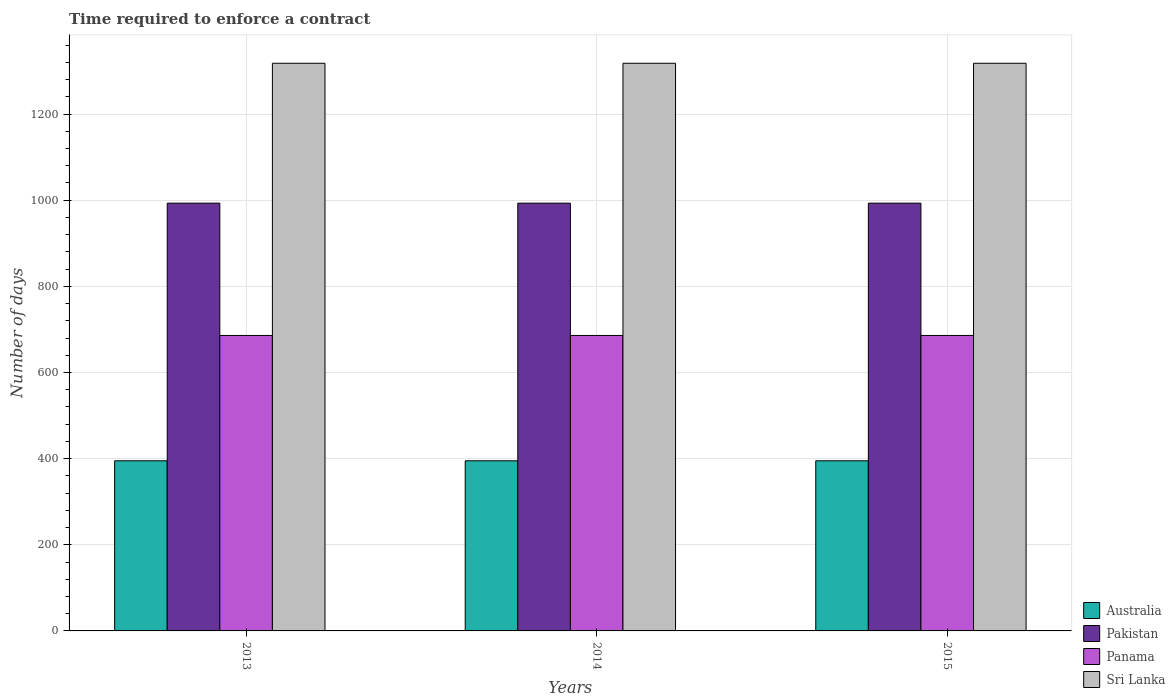How many different coloured bars are there?
Offer a very short reply. 4. Are the number of bars per tick equal to the number of legend labels?
Keep it short and to the point. Yes. Are the number of bars on each tick of the X-axis equal?
Ensure brevity in your answer.  Yes. How many bars are there on the 2nd tick from the right?
Your response must be concise. 4. What is the label of the 3rd group of bars from the left?
Ensure brevity in your answer.  2015. What is the number of days required to enforce a contract in Australia in 2013?
Provide a short and direct response. 395. Across all years, what is the maximum number of days required to enforce a contract in Australia?
Offer a terse response. 395. Across all years, what is the minimum number of days required to enforce a contract in Sri Lanka?
Offer a terse response. 1318. What is the total number of days required to enforce a contract in Pakistan in the graph?
Keep it short and to the point. 2979.6. What is the difference between the number of days required to enforce a contract in Australia in 2013 and that in 2015?
Provide a succinct answer. 0. What is the difference between the number of days required to enforce a contract in Pakistan in 2014 and the number of days required to enforce a contract in Sri Lanka in 2013?
Provide a short and direct response. -324.8. What is the average number of days required to enforce a contract in Pakistan per year?
Make the answer very short. 993.2. In the year 2014, what is the difference between the number of days required to enforce a contract in Sri Lanka and number of days required to enforce a contract in Australia?
Provide a succinct answer. 923. In how many years, is the number of days required to enforce a contract in Australia greater than 440 days?
Ensure brevity in your answer.  0. Is the number of days required to enforce a contract in Pakistan in 2013 less than that in 2014?
Offer a terse response. No. Is the difference between the number of days required to enforce a contract in Sri Lanka in 2013 and 2015 greater than the difference between the number of days required to enforce a contract in Australia in 2013 and 2015?
Offer a very short reply. No. What is the difference between the highest and the lowest number of days required to enforce a contract in Panama?
Your answer should be very brief. 0. What does the 4th bar from the left in 2015 represents?
Ensure brevity in your answer.  Sri Lanka. What does the 3rd bar from the right in 2013 represents?
Provide a succinct answer. Pakistan. Is it the case that in every year, the sum of the number of days required to enforce a contract in Australia and number of days required to enforce a contract in Pakistan is greater than the number of days required to enforce a contract in Panama?
Your response must be concise. Yes. How many bars are there?
Provide a succinct answer. 12. How many years are there in the graph?
Make the answer very short. 3. Does the graph contain any zero values?
Your answer should be compact. No. What is the title of the graph?
Keep it short and to the point. Time required to enforce a contract. What is the label or title of the Y-axis?
Make the answer very short. Number of days. What is the Number of days in Australia in 2013?
Make the answer very short. 395. What is the Number of days of Pakistan in 2013?
Offer a very short reply. 993.2. What is the Number of days in Panama in 2013?
Your answer should be very brief. 686. What is the Number of days of Sri Lanka in 2013?
Ensure brevity in your answer.  1318. What is the Number of days in Australia in 2014?
Offer a very short reply. 395. What is the Number of days of Pakistan in 2014?
Give a very brief answer. 993.2. What is the Number of days in Panama in 2014?
Your answer should be very brief. 686. What is the Number of days in Sri Lanka in 2014?
Keep it short and to the point. 1318. What is the Number of days of Australia in 2015?
Your answer should be compact. 395. What is the Number of days in Pakistan in 2015?
Your response must be concise. 993.2. What is the Number of days in Panama in 2015?
Provide a short and direct response. 686. What is the Number of days in Sri Lanka in 2015?
Your response must be concise. 1318. Across all years, what is the maximum Number of days of Australia?
Keep it short and to the point. 395. Across all years, what is the maximum Number of days of Pakistan?
Provide a short and direct response. 993.2. Across all years, what is the maximum Number of days in Panama?
Give a very brief answer. 686. Across all years, what is the maximum Number of days of Sri Lanka?
Your answer should be compact. 1318. Across all years, what is the minimum Number of days in Australia?
Your response must be concise. 395. Across all years, what is the minimum Number of days of Pakistan?
Your response must be concise. 993.2. Across all years, what is the minimum Number of days of Panama?
Your answer should be compact. 686. Across all years, what is the minimum Number of days in Sri Lanka?
Provide a short and direct response. 1318. What is the total Number of days in Australia in the graph?
Your answer should be compact. 1185. What is the total Number of days in Pakistan in the graph?
Your answer should be compact. 2979.6. What is the total Number of days in Panama in the graph?
Provide a succinct answer. 2058. What is the total Number of days of Sri Lanka in the graph?
Provide a succinct answer. 3954. What is the difference between the Number of days in Pakistan in 2013 and that in 2015?
Make the answer very short. 0. What is the difference between the Number of days in Sri Lanka in 2014 and that in 2015?
Make the answer very short. 0. What is the difference between the Number of days of Australia in 2013 and the Number of days of Pakistan in 2014?
Your response must be concise. -598.2. What is the difference between the Number of days in Australia in 2013 and the Number of days in Panama in 2014?
Provide a succinct answer. -291. What is the difference between the Number of days of Australia in 2013 and the Number of days of Sri Lanka in 2014?
Offer a terse response. -923. What is the difference between the Number of days of Pakistan in 2013 and the Number of days of Panama in 2014?
Offer a very short reply. 307.2. What is the difference between the Number of days in Pakistan in 2013 and the Number of days in Sri Lanka in 2014?
Provide a short and direct response. -324.8. What is the difference between the Number of days of Panama in 2013 and the Number of days of Sri Lanka in 2014?
Your response must be concise. -632. What is the difference between the Number of days in Australia in 2013 and the Number of days in Pakistan in 2015?
Make the answer very short. -598.2. What is the difference between the Number of days of Australia in 2013 and the Number of days of Panama in 2015?
Offer a terse response. -291. What is the difference between the Number of days in Australia in 2013 and the Number of days in Sri Lanka in 2015?
Give a very brief answer. -923. What is the difference between the Number of days in Pakistan in 2013 and the Number of days in Panama in 2015?
Your response must be concise. 307.2. What is the difference between the Number of days in Pakistan in 2013 and the Number of days in Sri Lanka in 2015?
Provide a short and direct response. -324.8. What is the difference between the Number of days of Panama in 2013 and the Number of days of Sri Lanka in 2015?
Your answer should be compact. -632. What is the difference between the Number of days in Australia in 2014 and the Number of days in Pakistan in 2015?
Provide a succinct answer. -598.2. What is the difference between the Number of days of Australia in 2014 and the Number of days of Panama in 2015?
Your answer should be very brief. -291. What is the difference between the Number of days in Australia in 2014 and the Number of days in Sri Lanka in 2015?
Your answer should be compact. -923. What is the difference between the Number of days of Pakistan in 2014 and the Number of days of Panama in 2015?
Ensure brevity in your answer.  307.2. What is the difference between the Number of days in Pakistan in 2014 and the Number of days in Sri Lanka in 2015?
Keep it short and to the point. -324.8. What is the difference between the Number of days of Panama in 2014 and the Number of days of Sri Lanka in 2015?
Your answer should be compact. -632. What is the average Number of days of Australia per year?
Provide a short and direct response. 395. What is the average Number of days in Pakistan per year?
Give a very brief answer. 993.2. What is the average Number of days of Panama per year?
Your answer should be compact. 686. What is the average Number of days of Sri Lanka per year?
Make the answer very short. 1318. In the year 2013, what is the difference between the Number of days in Australia and Number of days in Pakistan?
Your response must be concise. -598.2. In the year 2013, what is the difference between the Number of days of Australia and Number of days of Panama?
Provide a succinct answer. -291. In the year 2013, what is the difference between the Number of days of Australia and Number of days of Sri Lanka?
Offer a terse response. -923. In the year 2013, what is the difference between the Number of days of Pakistan and Number of days of Panama?
Provide a succinct answer. 307.2. In the year 2013, what is the difference between the Number of days in Pakistan and Number of days in Sri Lanka?
Offer a very short reply. -324.8. In the year 2013, what is the difference between the Number of days in Panama and Number of days in Sri Lanka?
Keep it short and to the point. -632. In the year 2014, what is the difference between the Number of days of Australia and Number of days of Pakistan?
Your answer should be compact. -598.2. In the year 2014, what is the difference between the Number of days of Australia and Number of days of Panama?
Your response must be concise. -291. In the year 2014, what is the difference between the Number of days in Australia and Number of days in Sri Lanka?
Your response must be concise. -923. In the year 2014, what is the difference between the Number of days in Pakistan and Number of days in Panama?
Ensure brevity in your answer.  307.2. In the year 2014, what is the difference between the Number of days in Pakistan and Number of days in Sri Lanka?
Provide a succinct answer. -324.8. In the year 2014, what is the difference between the Number of days in Panama and Number of days in Sri Lanka?
Ensure brevity in your answer.  -632. In the year 2015, what is the difference between the Number of days in Australia and Number of days in Pakistan?
Your answer should be very brief. -598.2. In the year 2015, what is the difference between the Number of days of Australia and Number of days of Panama?
Offer a terse response. -291. In the year 2015, what is the difference between the Number of days of Australia and Number of days of Sri Lanka?
Your answer should be very brief. -923. In the year 2015, what is the difference between the Number of days of Pakistan and Number of days of Panama?
Your answer should be compact. 307.2. In the year 2015, what is the difference between the Number of days in Pakistan and Number of days in Sri Lanka?
Provide a succinct answer. -324.8. In the year 2015, what is the difference between the Number of days of Panama and Number of days of Sri Lanka?
Give a very brief answer. -632. What is the ratio of the Number of days in Pakistan in 2013 to that in 2014?
Provide a succinct answer. 1. What is the ratio of the Number of days in Panama in 2013 to that in 2014?
Your answer should be compact. 1. What is the ratio of the Number of days of Sri Lanka in 2013 to that in 2014?
Offer a terse response. 1. What is the ratio of the Number of days of Australia in 2013 to that in 2015?
Offer a terse response. 1. What is the ratio of the Number of days of Pakistan in 2013 to that in 2015?
Keep it short and to the point. 1. What is the ratio of the Number of days in Panama in 2013 to that in 2015?
Make the answer very short. 1. What is the ratio of the Number of days in Sri Lanka in 2013 to that in 2015?
Your response must be concise. 1. What is the ratio of the Number of days of Australia in 2014 to that in 2015?
Make the answer very short. 1. What is the ratio of the Number of days in Pakistan in 2014 to that in 2015?
Your answer should be very brief. 1. What is the ratio of the Number of days of Sri Lanka in 2014 to that in 2015?
Your answer should be compact. 1. What is the difference between the highest and the second highest Number of days in Australia?
Give a very brief answer. 0. What is the difference between the highest and the lowest Number of days in Pakistan?
Ensure brevity in your answer.  0. What is the difference between the highest and the lowest Number of days in Panama?
Offer a very short reply. 0. 